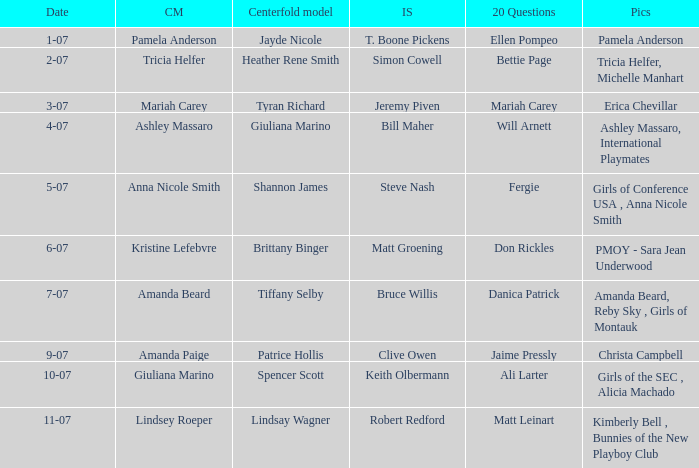List the pictorals from issues when lindsey roeper was the cover model. Kimberly Bell , Bunnies of the New Playboy Club. 